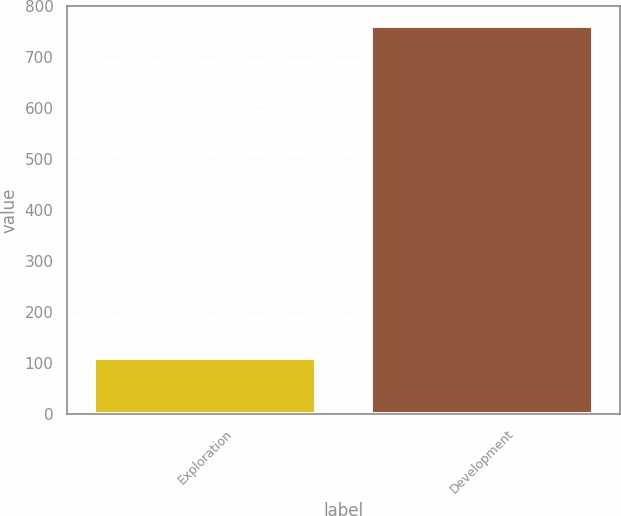Convert chart to OTSL. <chart><loc_0><loc_0><loc_500><loc_500><bar_chart><fcel>Exploration<fcel>Development<nl><fcel>111<fcel>762<nl></chart> 